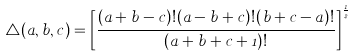Convert formula to latex. <formula><loc_0><loc_0><loc_500><loc_500>\triangle ( a , b , c ) = \left [ \frac { ( a + b - c ) ! ( a - b + c ) ! ( b + c - a ) ! } { ( a + b + c + 1 ) ! } \right ] ^ { \frac { 1 } { 2 } }</formula> 